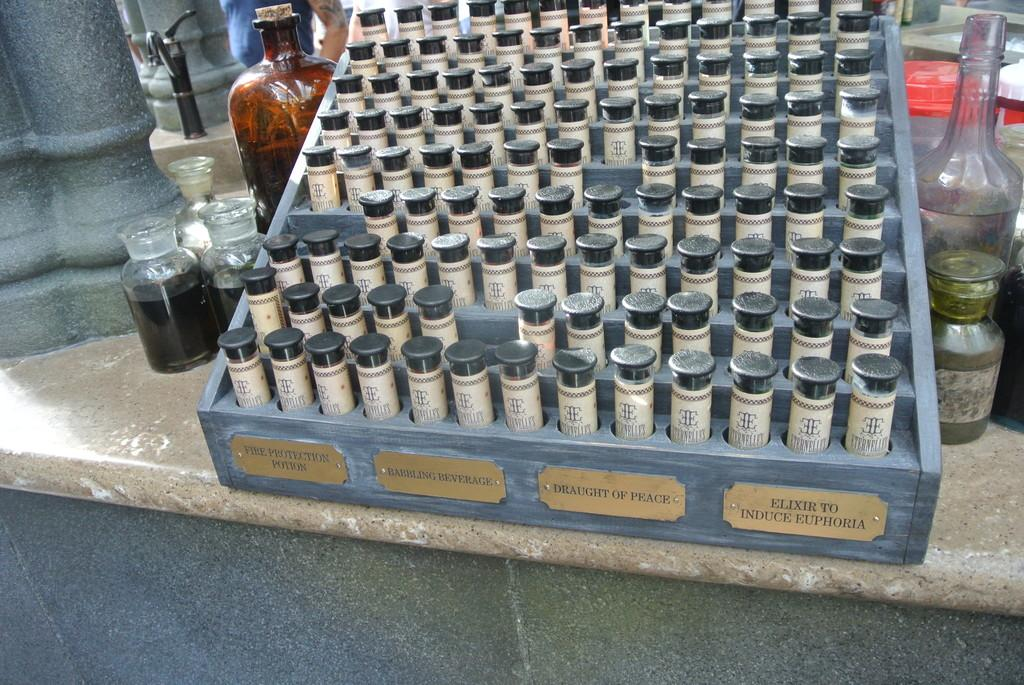What is the main subject of the image? The main subject of the image is objects fixed to a board. Can you describe the board in the image? There is a name board in the image. What can be seen on the table in the image? There are glass jars and a glass bottle on a table in the image. What type of base is used for the volleyball game in the image? There is no volleyball game present in the image, so it is not possible to determine the type of base used. 